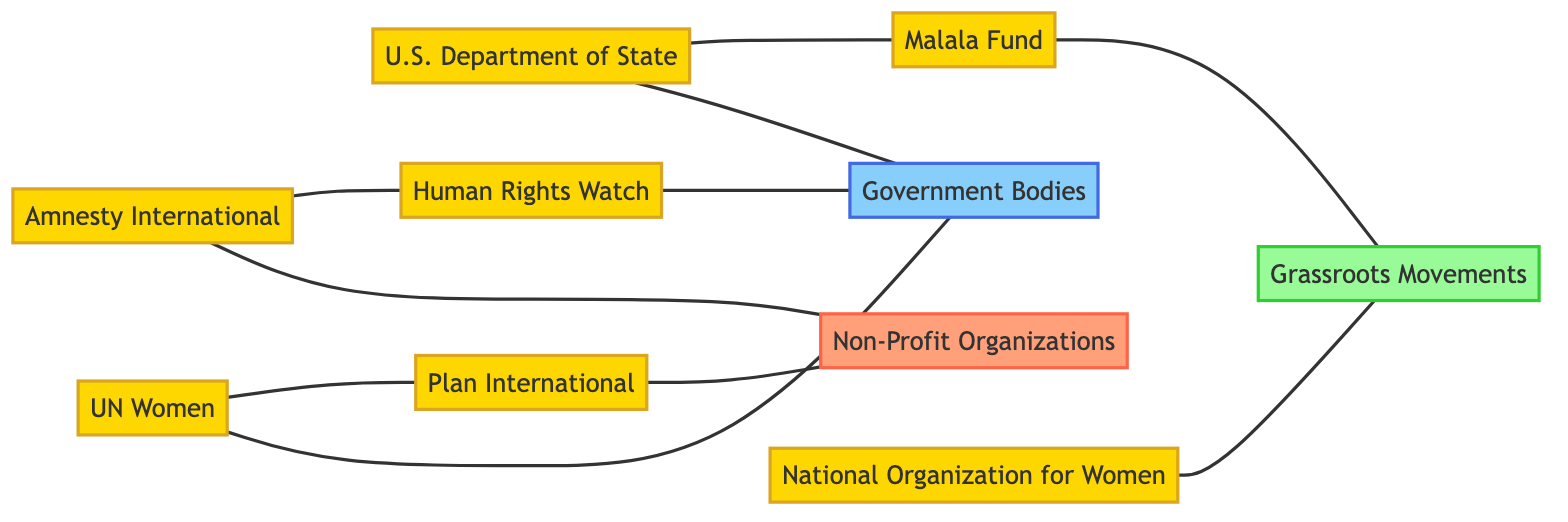What are the types of organizations represented in the diagram? The diagram contains three types of organizations: Non-Profit Organizations, Government Bodies, and Grassroots Movements. Each category has specific organizations listed under it.
Answer: Non-Profit Organizations, Government Bodies, Grassroots Movements How many nodes are present in the diagram? By counting the distinct entities listed in the nodes section, we can determine that there are ten nodes in total.
Answer: 10 Which organization collaborates with government bodies? The edge between "UN Women" and "Government Bodies" indicates that UN Women collaborates with them, as described by the label on the edge.
Answer: UN Women What does Amnesty International do for non-profit organizations? The diagram shows that Amnesty International "Supports" non-profit organizations, which is indicated by the label on the edge connecting them.
Answer: Supports How many organizations empower grassroots movements? The diagram indicates that "Malala Fund" is the only organization that specifically empowers grassroots movements, as shown by the direct edge connecting them.
Answer: 1 Which organization coordinates with Plan International? The diagram shows that "UN Women" coordinates with Plan International, which can be seen from the labeled edge between them.
Answer: UN Women What is the relationship between U.S. Department of State and Malala Fund? There is an edge illustrating that the U.S. Department of State "Provides grants to" Malala Fund, indicating a financial support relationship.
Answer: Provides grants to How many edges are shown in the diagram? The edges listed detail the connections between the organizations. By counting them, we can find that there are nine edges in total.
Answer: 9 Which organizations mobilize grassroots movements? The edge shows that "National Organization for Women" mobilizes grassroots movements, as indicated by the label connecting them.
Answer: National Organization for Women (NOW) 